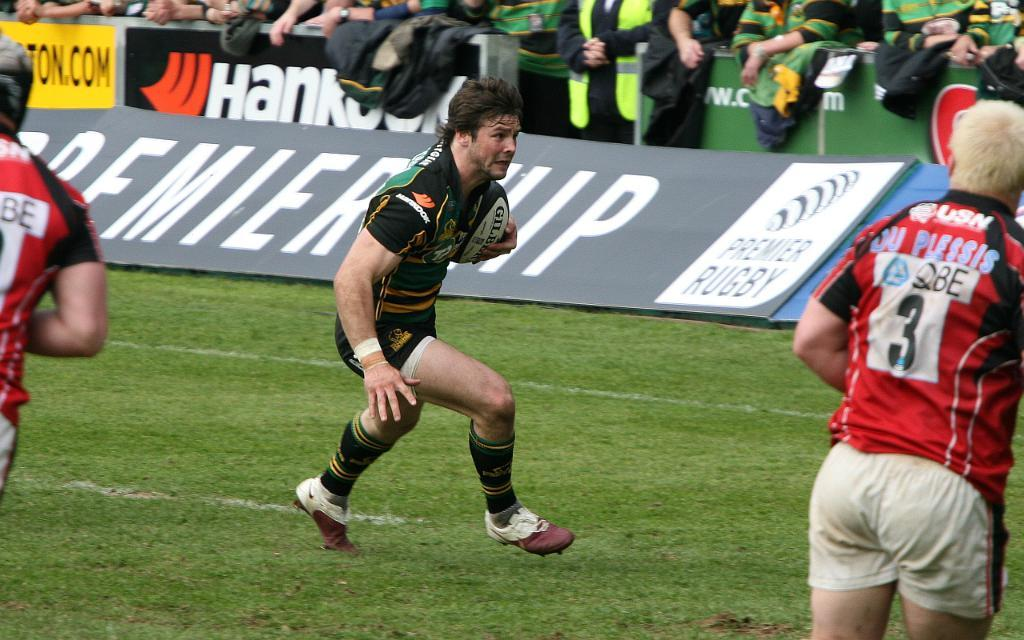What sport are the players engaged in within the image? The players are playing rugby in the image. Where is the rugby game taking place? The rugby game is taking place on the ground. What can be seen in the background of the image? There are banners in the background of the image. What is the position of the people behind the banners? People are standing behind the banners. What type of deer can be seen running across the rugby field in the image? There are no deer present in the image; it features a rugby game taking place on the ground. How many gallons of milk are being consumed by the players during the game in the image? There is no information about milk consumption in the image, as it focuses on the rugby game. 